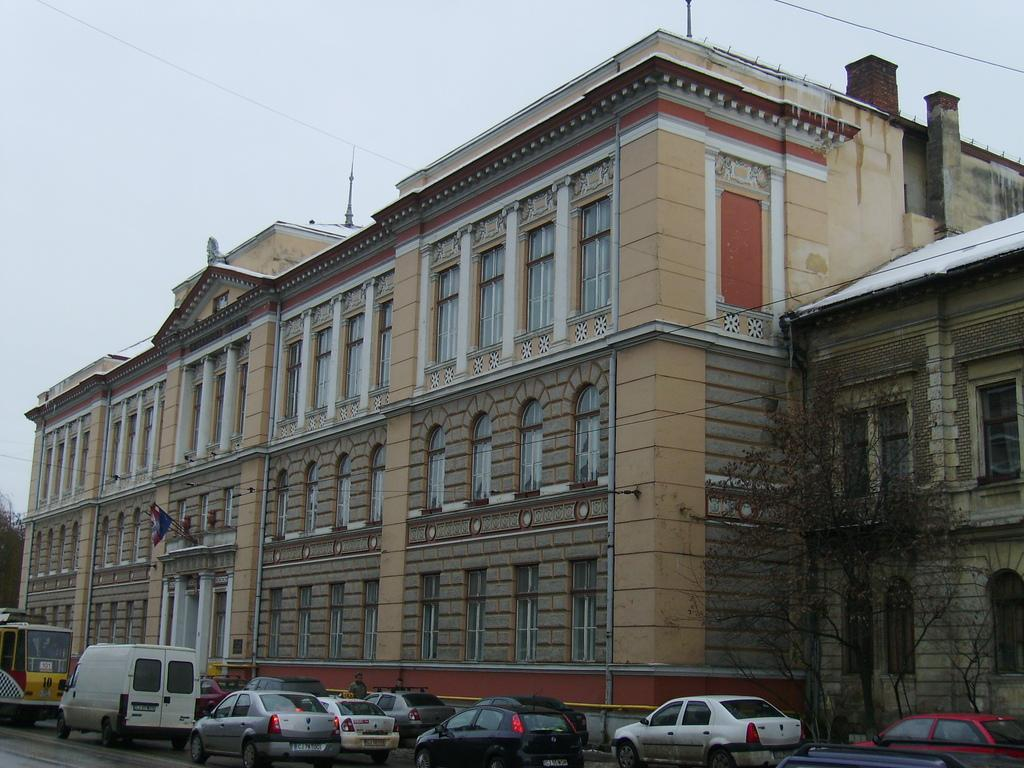What can be seen on the road in the image? There are vehicles on the road in the image. What is visible in the background of the image? Buildings, windows, a flag, trees, poles, wires, and the sky are visible in the background. Can you describe the flag in the image? The flag is in the background, but its specific design or color cannot be determined from the image. What type of knot is used to secure the neck of the flag in the image? There is no knot visible in the image, and the flag's neck is not mentioned in the provided facts. Additionally, there is no indication that the flag is tied or secured in any way. 